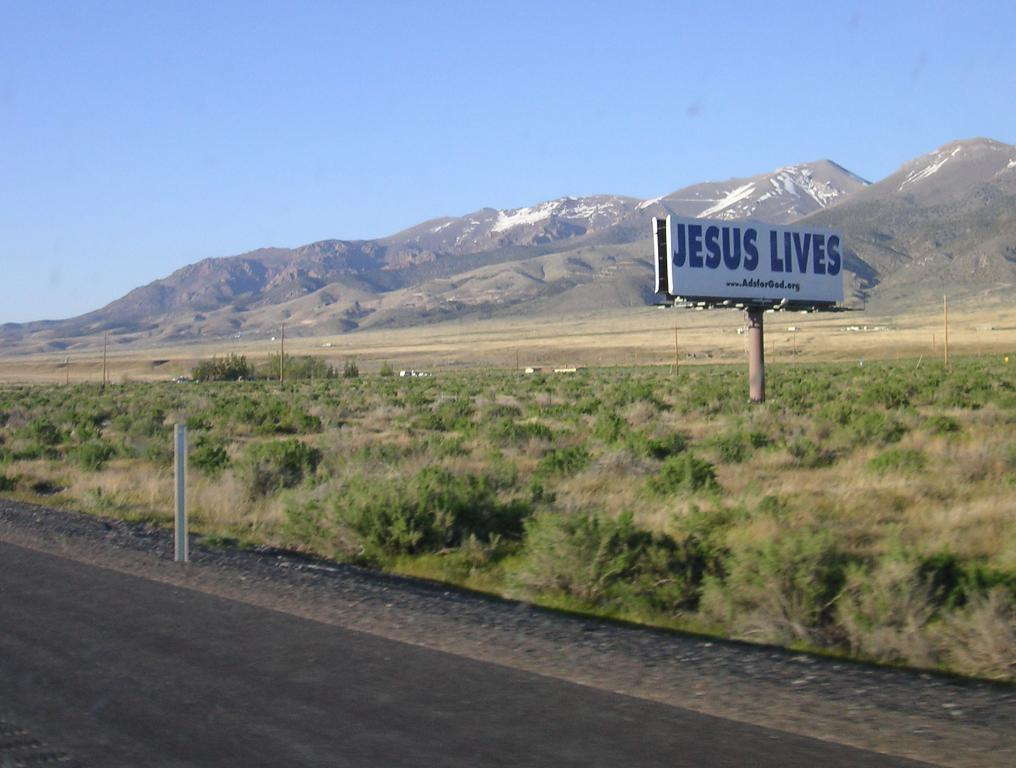<image>
Share a concise interpretation of the image provided. Even in the middle of nowhere there are "Jesus Lives" billboards. 